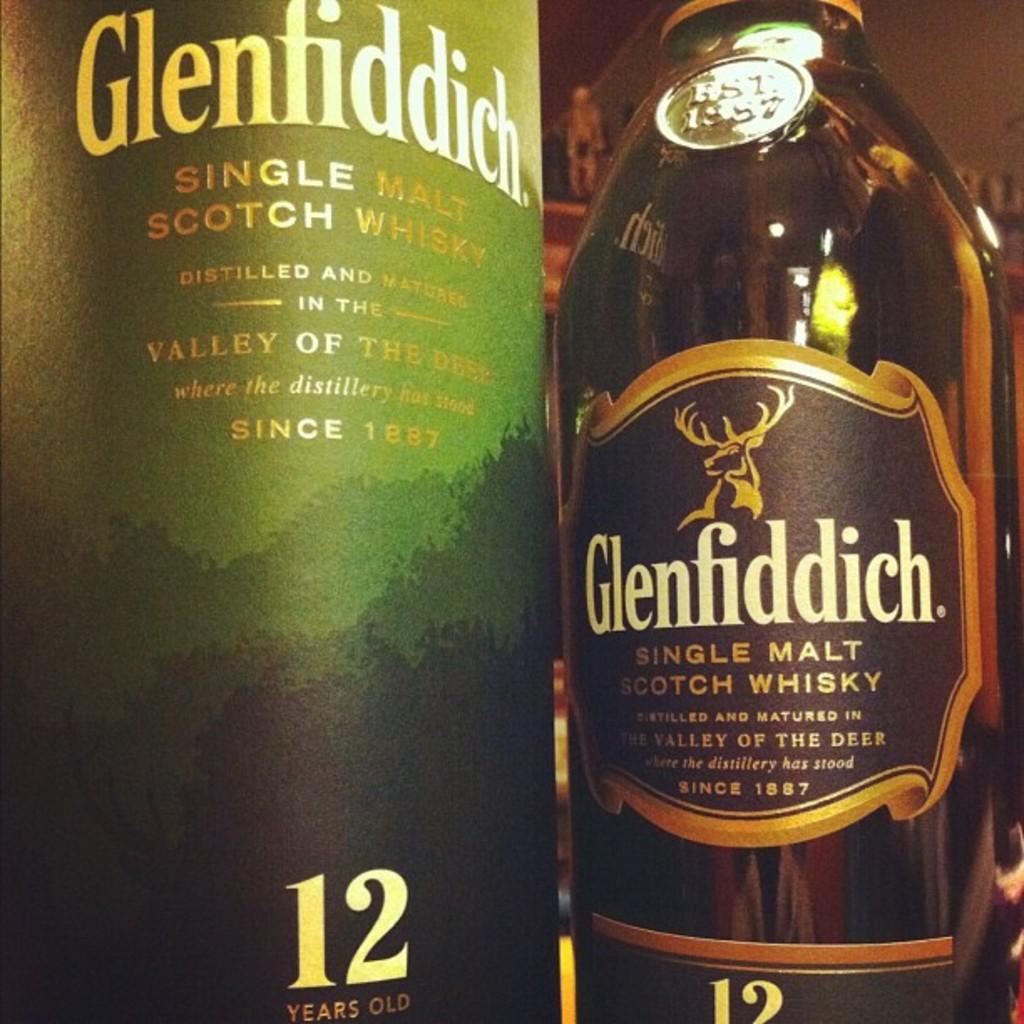What kind of liquor is glennfiddich?
Ensure brevity in your answer.  Single malt scotch whisky. How many years old is the beverage on the left?
Ensure brevity in your answer.  12. 